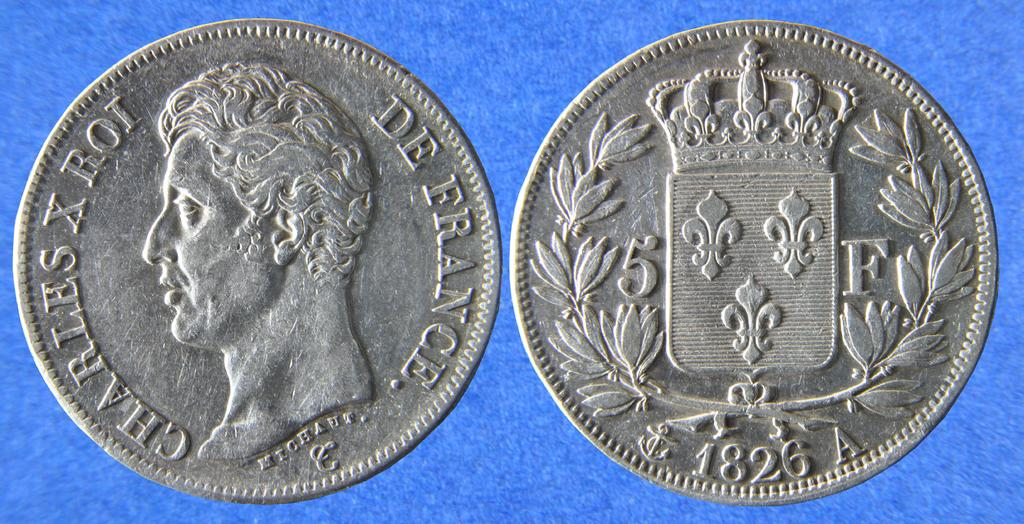<image>
Relay a brief, clear account of the picture shown. Front and back of a coin with the front saying Charles X Roi. 